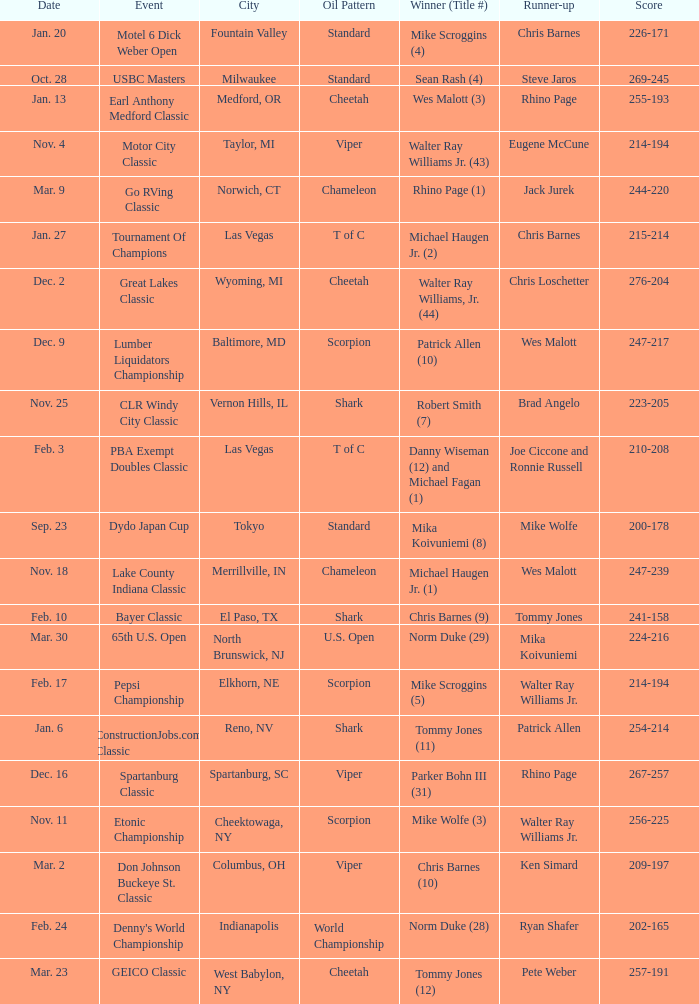Identify the event in which parker bohn iii won his 31st title. Spartanburg Classic. 